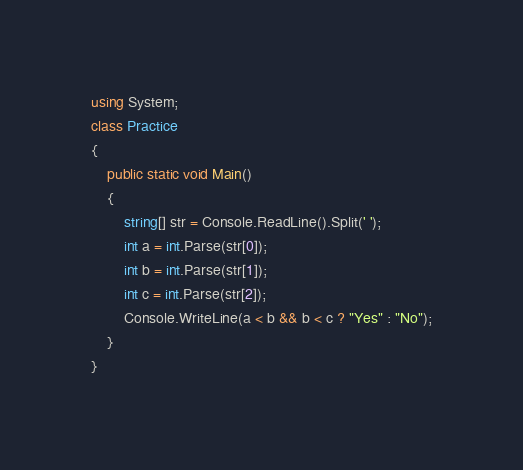<code> <loc_0><loc_0><loc_500><loc_500><_C#_>using System;
class Practice
{
    public static void Main()
    {
        string[] str = Console.ReadLine().Split(' ');
        int a = int.Parse(str[0]);
        int b = int.Parse(str[1]);
        int c = int.Parse(str[2]);
        Console.WriteLine(a < b && b < c ? "Yes" : "No");
    }
}
</code> 